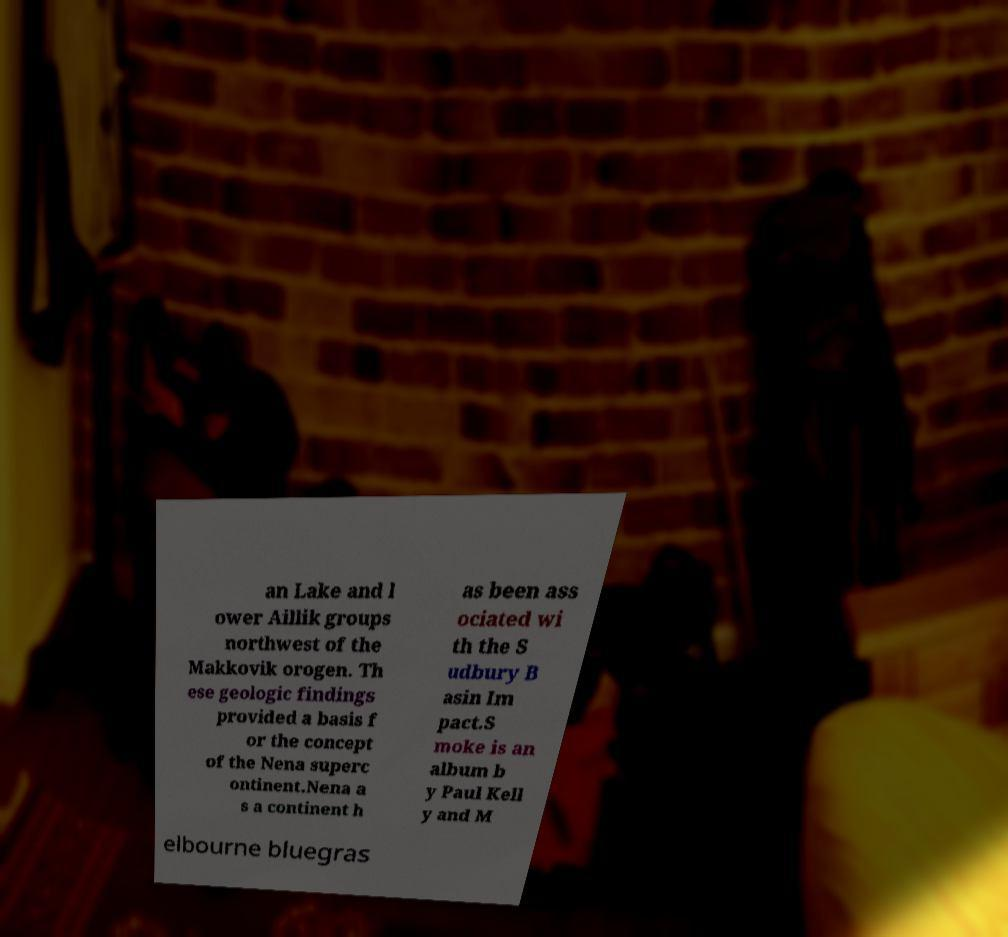Please read and relay the text visible in this image. What does it say? an Lake and l ower Aillik groups northwest of the Makkovik orogen. Th ese geologic findings provided a basis f or the concept of the Nena superc ontinent.Nena a s a continent h as been ass ociated wi th the S udbury B asin Im pact.S moke is an album b y Paul Kell y and M elbourne bluegras 